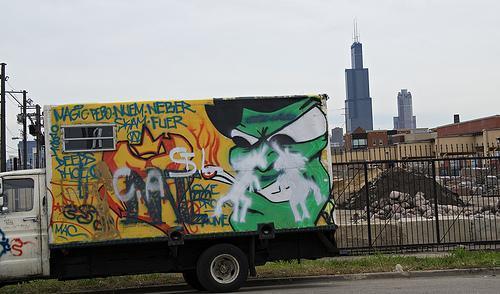How many truck wheels are visible?
Give a very brief answer. 1. 